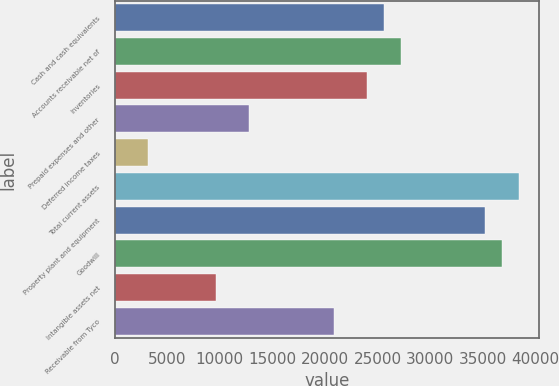Convert chart. <chart><loc_0><loc_0><loc_500><loc_500><bar_chart><fcel>Cash and cash equivalents<fcel>Accounts receivable net of<fcel>Inventories<fcel>Prepaid expenses and other<fcel>Deferred income taxes<fcel>Total current assets<fcel>Property plant and equipment<fcel>Goodwill<fcel>Intangible assets net<fcel>Receivable from Tyco<nl><fcel>25622.8<fcel>27223.6<fcel>24022<fcel>12816.4<fcel>3211.6<fcel>38429.2<fcel>35227.6<fcel>36828.4<fcel>9614.8<fcel>20820.4<nl></chart> 